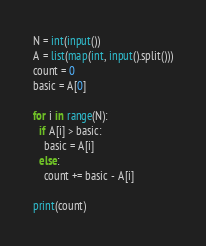Convert code to text. <code><loc_0><loc_0><loc_500><loc_500><_Python_>N = int(input())
A = list(map(int, input().split()))
count = 0
basic = A[0]

for i in range(N):
  if A[i] > basic:
    basic = A[i]
  else:    
    count += basic - A[i]

print(count)</code> 